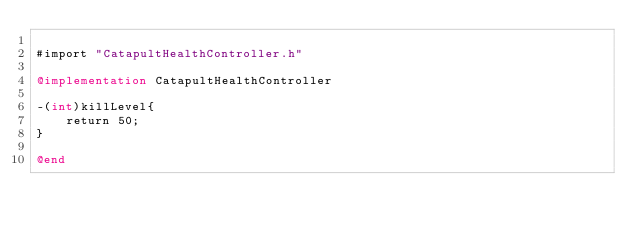Convert code to text. <code><loc_0><loc_0><loc_500><loc_500><_ObjectiveC_>
#import "CatapultHealthController.h"

@implementation CatapultHealthController

-(int)killLevel{
    return 50;
}

@end
</code> 